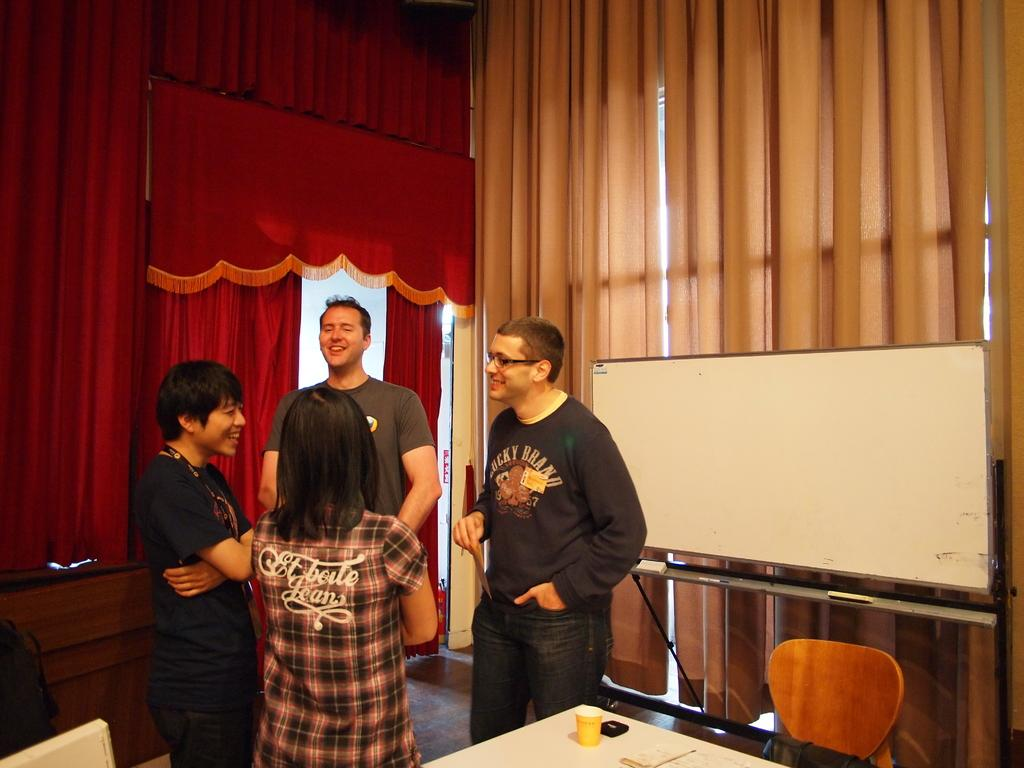How many people are present in the image? There are four people standing in the image. What are the people doing in the image? The people are talking to each other. What can be seen in the background of the image? There are red and brown curtains in the background of the image. What type of amusement can be seen in the image? There is no amusement present in the image; it features four people talking to each other. Can you provide an example of the father in the image? There is no father mentioned in the image, nor are there any family relationships specified. 